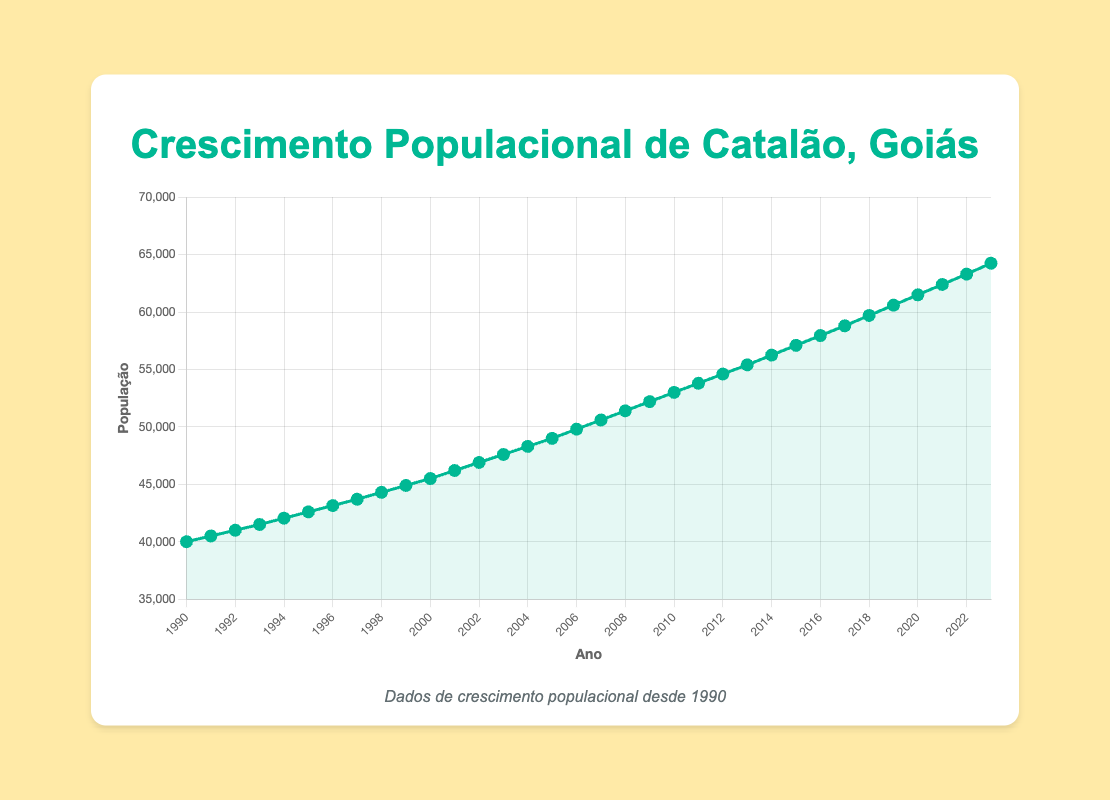What is the population of Catalão, Goiás in 1995? The population data point for 1995 is marked on the line plot. Locate the year 1995 on the x-axis and read the corresponding population value on the y-axis.
Answer: 42600 How much did the population increase from 2000 to 2010? Find the population values for both 2000 and 2010. Subtract the population value of 2000 from the population value of 2010 to get the increase. Population in 2010 (53000) - Population in 2000 (45500) = 7500
Answer: 7500 What year saw a population increase to 50000? Locate the point where the population first reaches 50000 by following the line. Identify the corresponding year on the x-axis when the population hit this mark.
Answer: 2006 Which decade experienced the highest overall increase in population? Sum up the population values at the start and end of each decade (1990-2000, 2000-2010, 2010-2020). The decade with the greatest difference in starting and ending population values had the highest increase. For 1990-2000: 45500 - 40000 = 5500. For 2000-2010: 53000 - 45500 = 7500. For 2010-2020: 61500 - 53000 = 8500. Hence, the decade 2010-2020 shows the highest increase.
Answer: 2010-2020 What is the overall trend in the population growth from 1990 to 2023? Observe the line plot connecting all data points from 1990 to 2023. The line shows a consistently rising trend indicating continuous population growth over these years.
Answer: Increasing By approximately how many people did the population grow on average each year from 1990 to 2023? To find the average annual growth, take the population increase over the entire period and divide it by the number of years. Population in 2023 (64250) - Population in 1990 (40000) = 24250. Number of years = 2023 - 1990 = 33. Average annual growth = 24250 / 33 ≈ 735.61
Answer: ~735 In which year was the population approximately half of what it was in 2023? Divide the population of 2023 by 2 to find approximately half the population, then find the nearest year in the dataset where the population was close to this value. Population in 2023 (64250) / 2 ≈ 32125. Search the years and see that in no year exactly matches this population, hence refining to the nearest guess which is earlier years.
Answer: Earlier Years than 1990 How does the population in 1995 compare with that in 2005? Locate the population values for the years 1995 and 2005 on the y-axis, then subtract the value for 1995 from the value for 2005 in the plot. Population in 2005 (49000) - Population in 1995 (42600) = 6400
Answer: Increased by 6400 